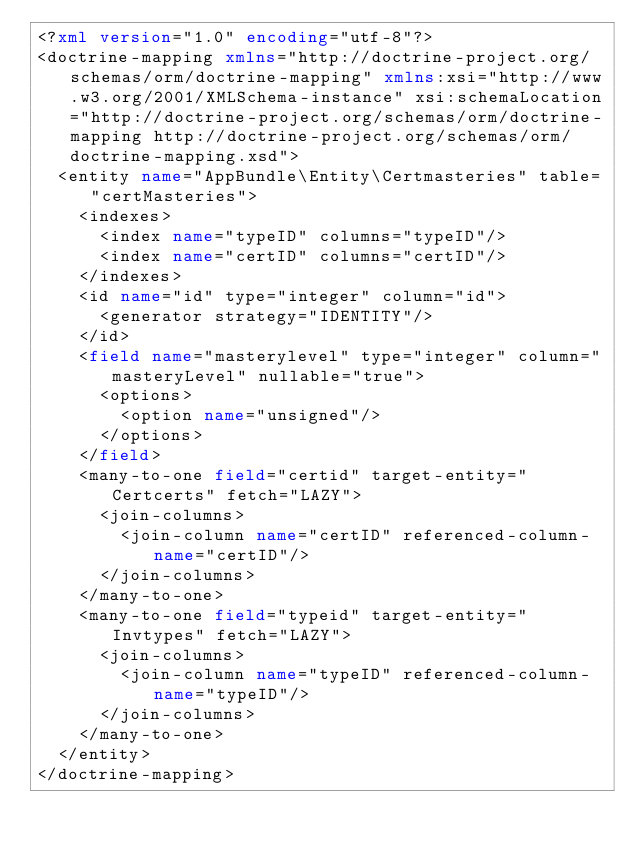<code> <loc_0><loc_0><loc_500><loc_500><_XML_><?xml version="1.0" encoding="utf-8"?>
<doctrine-mapping xmlns="http://doctrine-project.org/schemas/orm/doctrine-mapping" xmlns:xsi="http://www.w3.org/2001/XMLSchema-instance" xsi:schemaLocation="http://doctrine-project.org/schemas/orm/doctrine-mapping http://doctrine-project.org/schemas/orm/doctrine-mapping.xsd">
  <entity name="AppBundle\Entity\Certmasteries" table="certMasteries">
    <indexes>
      <index name="typeID" columns="typeID"/>
      <index name="certID" columns="certID"/>
    </indexes>
    <id name="id" type="integer" column="id">
      <generator strategy="IDENTITY"/>
    </id>
    <field name="masterylevel" type="integer" column="masteryLevel" nullable="true">
      <options>
        <option name="unsigned"/>
      </options>
    </field>
    <many-to-one field="certid" target-entity="Certcerts" fetch="LAZY">
      <join-columns>
        <join-column name="certID" referenced-column-name="certID"/>
      </join-columns>
    </many-to-one>
    <many-to-one field="typeid" target-entity="Invtypes" fetch="LAZY">
      <join-columns>
        <join-column name="typeID" referenced-column-name="typeID"/>
      </join-columns>
    </many-to-one>
  </entity>
</doctrine-mapping>
</code> 